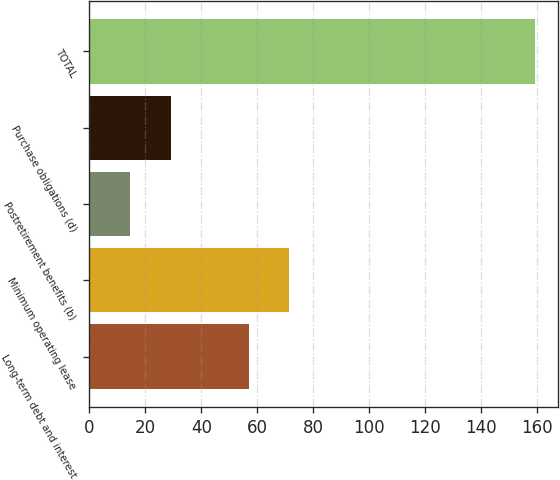Convert chart to OTSL. <chart><loc_0><loc_0><loc_500><loc_500><bar_chart><fcel>Long-term debt and interest<fcel>Minimum operating lease<fcel>Postretirement benefits (b)<fcel>Purchase obligations (d)<fcel>TOTAL<nl><fcel>56.9<fcel>71.38<fcel>14.6<fcel>29.08<fcel>159.4<nl></chart> 